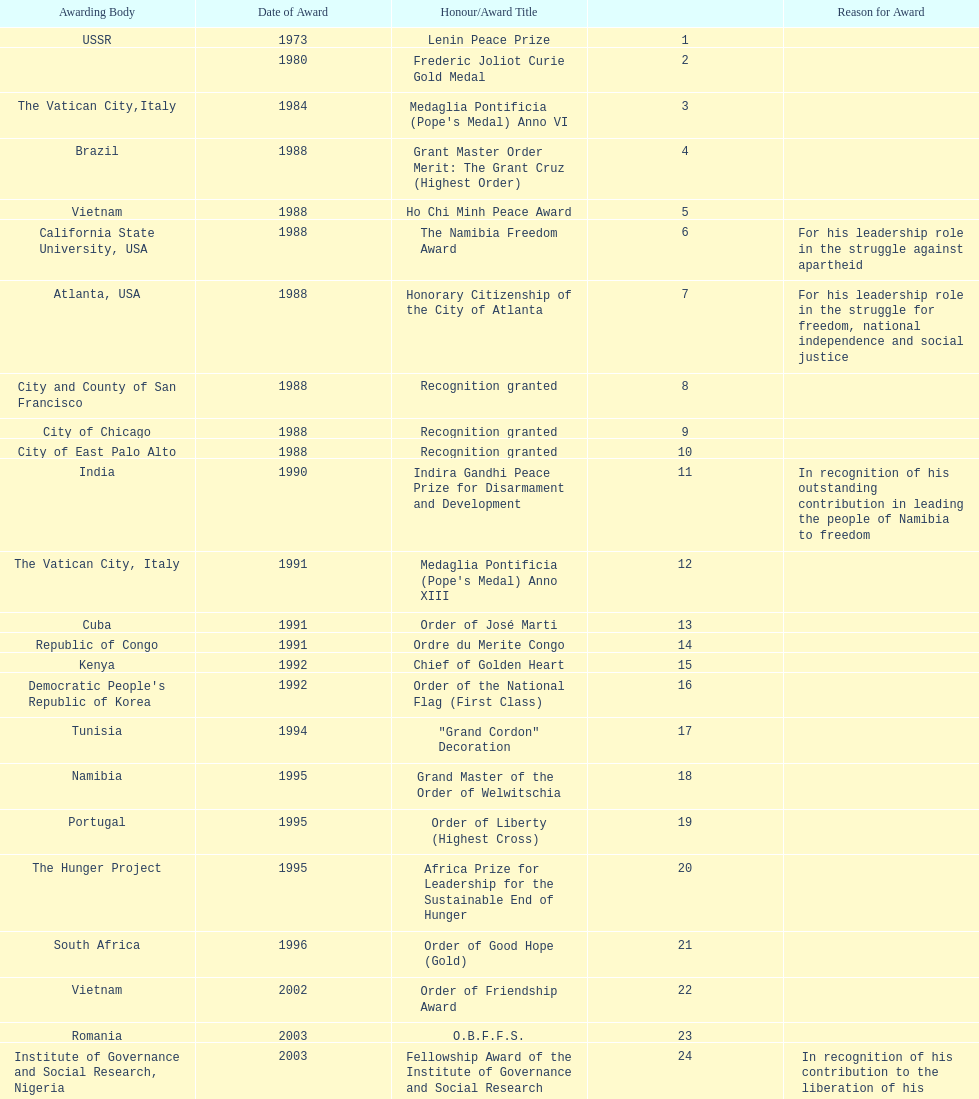What is the most recent award nujoma received? Sir Seretse Khama SADC Meda. 